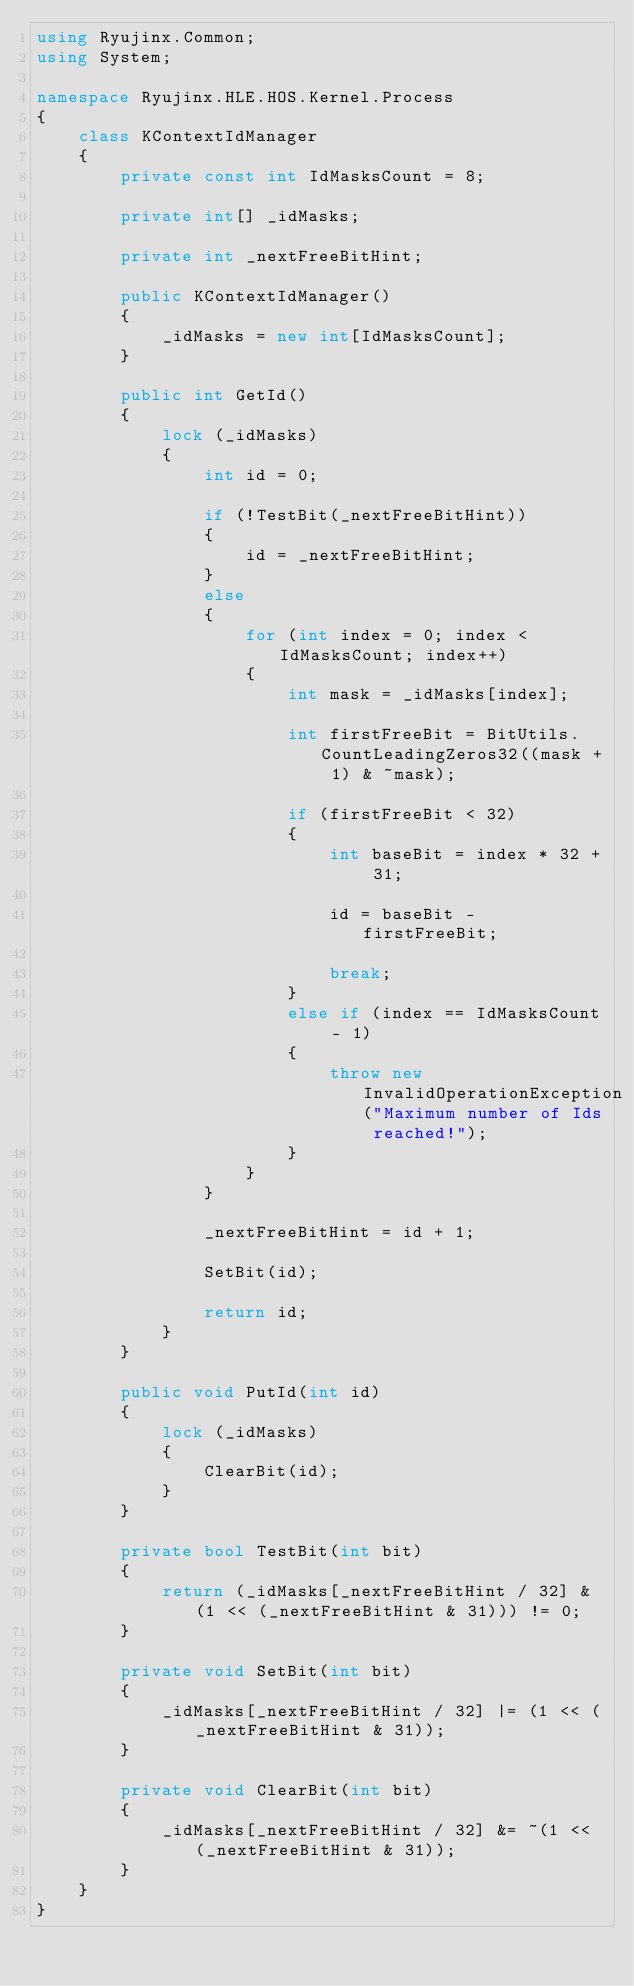Convert code to text. <code><loc_0><loc_0><loc_500><loc_500><_C#_>using Ryujinx.Common;
using System;

namespace Ryujinx.HLE.HOS.Kernel.Process
{
    class KContextIdManager
    {
        private const int IdMasksCount = 8;

        private int[] _idMasks;

        private int _nextFreeBitHint;

        public KContextIdManager()
        {
            _idMasks = new int[IdMasksCount];
        }

        public int GetId()
        {
            lock (_idMasks)
            {
                int id = 0;

                if (!TestBit(_nextFreeBitHint))
                {
                    id = _nextFreeBitHint;
                }
                else
                {
                    for (int index = 0; index < IdMasksCount; index++)
                    {
                        int mask = _idMasks[index];

                        int firstFreeBit = BitUtils.CountLeadingZeros32((mask + 1) & ~mask);

                        if (firstFreeBit < 32)
                        {
                            int baseBit = index * 32 + 31;

                            id = baseBit - firstFreeBit;

                            break;
                        }
                        else if (index == IdMasksCount - 1)
                        {
                            throw new InvalidOperationException("Maximum number of Ids reached!");
                        }
                    }
                }

                _nextFreeBitHint = id + 1;

                SetBit(id);

                return id;
            }
        }

        public void PutId(int id)
        {
            lock (_idMasks)
            {
                ClearBit(id);
            }
        }

        private bool TestBit(int bit)
        {
            return (_idMasks[_nextFreeBitHint / 32] & (1 << (_nextFreeBitHint & 31))) != 0;
        }

        private void SetBit(int bit)
        {
            _idMasks[_nextFreeBitHint / 32] |= (1 << (_nextFreeBitHint & 31));
        }

        private void ClearBit(int bit)
        {
            _idMasks[_nextFreeBitHint / 32] &= ~(1 << (_nextFreeBitHint & 31));
        }
    }
}</code> 